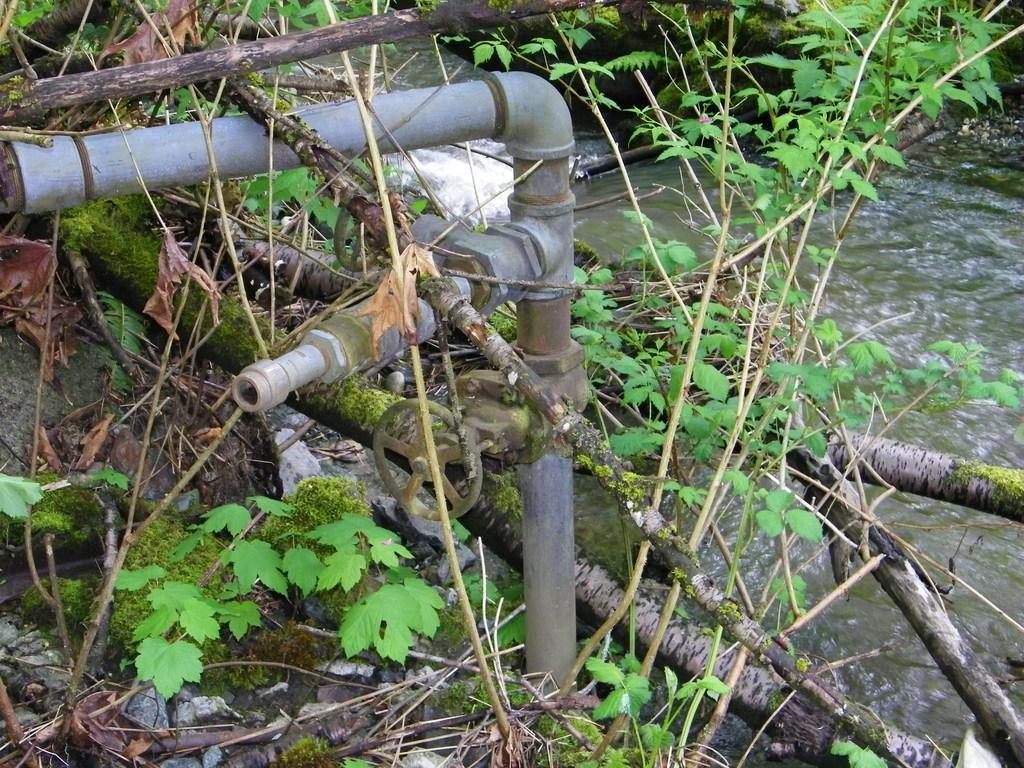In one or two sentences, can you explain what this image depicts? In this image we can see some plants, sticks, water, pipes, a wheel, also we can see some stones, and leaves on the ground. 